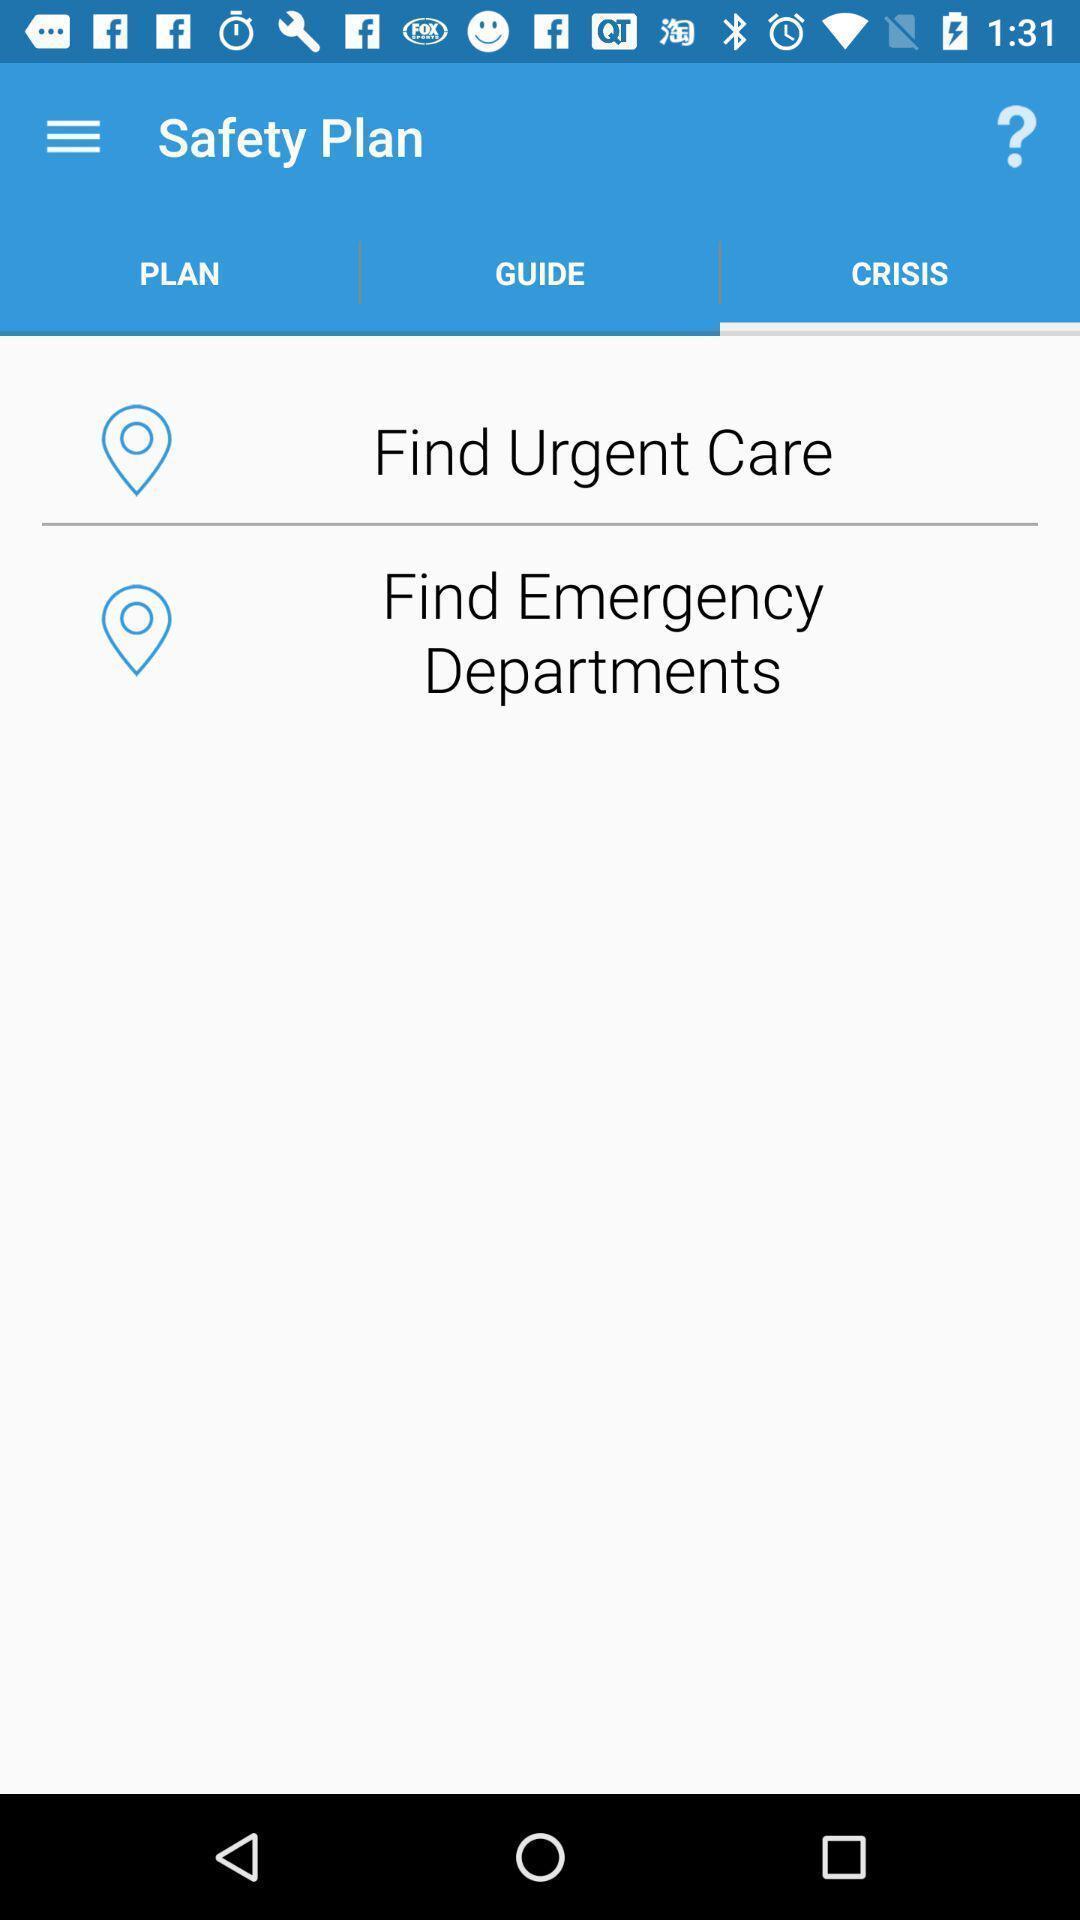Please provide a description for this image. Screen of safety plan in healthcare app. 